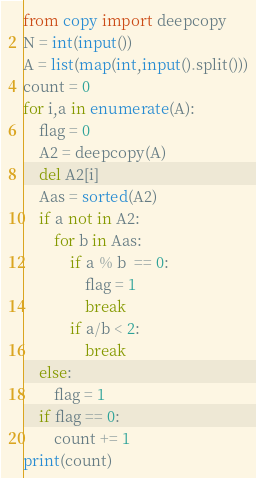Convert code to text. <code><loc_0><loc_0><loc_500><loc_500><_Python_>from copy import deepcopy
N = int(input())
A = list(map(int,input().split()))
count = 0
for i,a in enumerate(A):
    flag = 0
    A2 = deepcopy(A)
    del A2[i]
    Aas = sorted(A2)
    if a not in A2:
        for b in Aas:
            if a % b  == 0:
                flag = 1
                break
            if a/b < 2:
                break
    else:
        flag = 1
    if flag == 0:
        count += 1
print(count)
</code> 